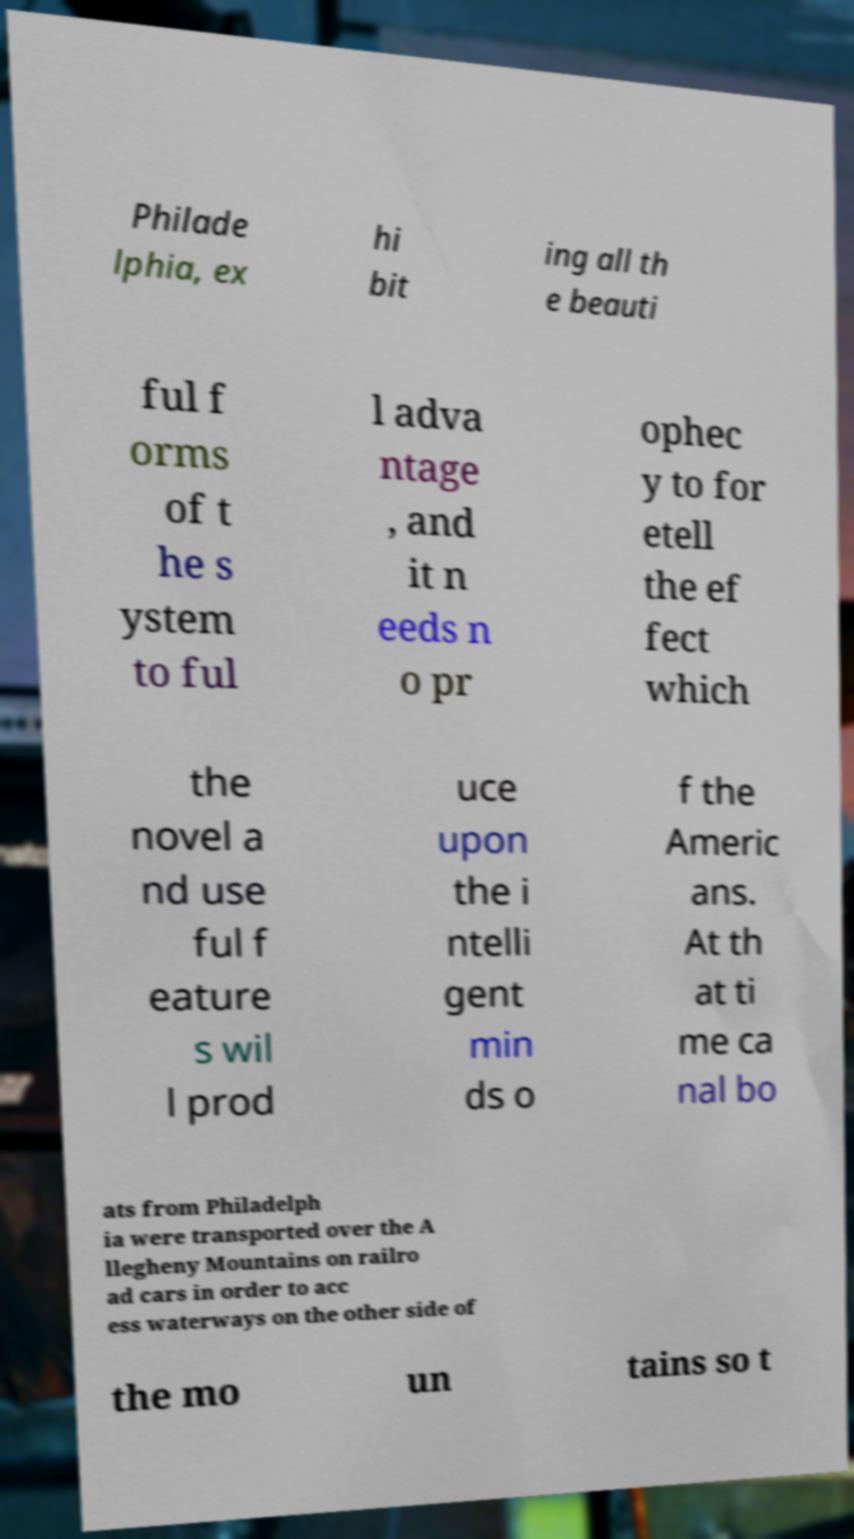What messages or text are displayed in this image? I need them in a readable, typed format. Philade lphia, ex hi bit ing all th e beauti ful f orms of t he s ystem to ful l adva ntage , and it n eeds n o pr ophec y to for etell the ef fect which the novel a nd use ful f eature s wil l prod uce upon the i ntelli gent min ds o f the Americ ans. At th at ti me ca nal bo ats from Philadelph ia were transported over the A llegheny Mountains on railro ad cars in order to acc ess waterways on the other side of the mo un tains so t 